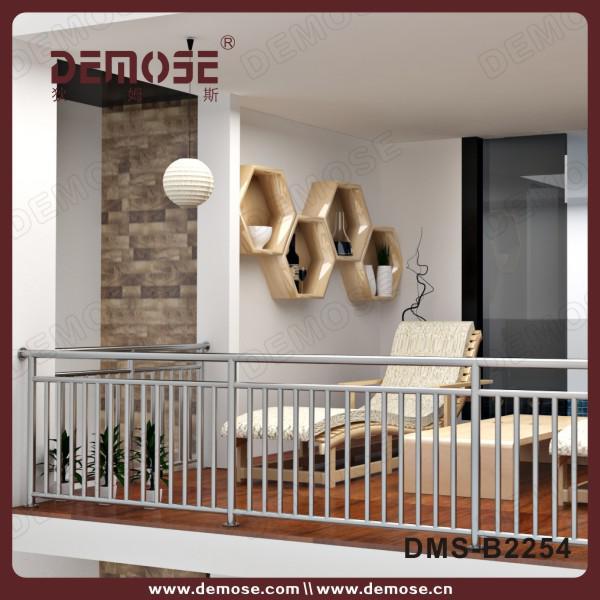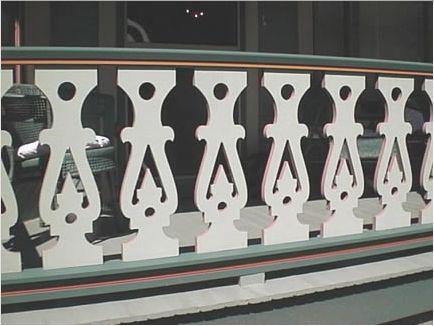The first image is the image on the left, the second image is the image on the right. Analyze the images presented: Is the assertion "The left image shows a white-painted rail with decorative geometric cut-outs instead of spindles, above red brick." valid? Answer yes or no. No. 